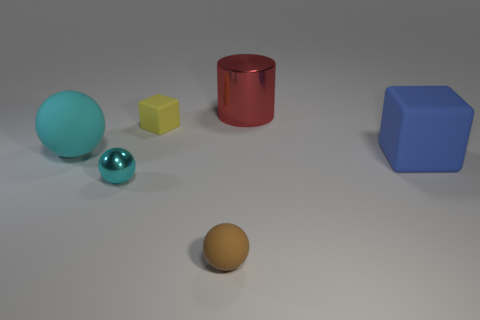Do the small cyan thing and the large thing behind the tiny yellow matte object have the same shape?
Keep it short and to the point. No. How many balls are red metallic objects or small metal objects?
Keep it short and to the point. 1. There is a tiny matte object behind the cyan matte thing; what shape is it?
Provide a short and direct response. Cube. How many small yellow objects have the same material as the blue block?
Give a very brief answer. 1. Is the number of small brown things to the right of the large shiny object less than the number of large green balls?
Keep it short and to the point. No. There is a rubber sphere that is behind the big blue rubber object in front of the big red shiny cylinder; what is its size?
Provide a short and direct response. Large. Is the color of the tiny metal thing the same as the sphere right of the small yellow matte cube?
Offer a very short reply. No. There is a brown sphere that is the same size as the cyan metal ball; what material is it?
Your answer should be very brief. Rubber. Is the number of yellow matte things that are in front of the tiny brown matte sphere less than the number of small yellow things that are to the right of the small yellow matte thing?
Offer a very short reply. No. The metal object that is in front of the large rubber thing behind the blue thing is what shape?
Ensure brevity in your answer.  Sphere. 